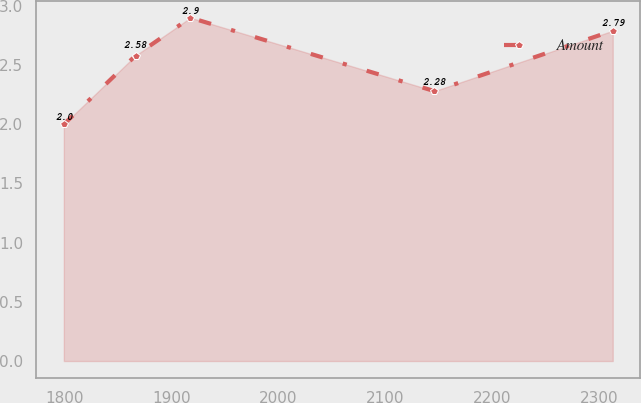Convert chart to OTSL. <chart><loc_0><loc_0><loc_500><loc_500><line_chart><ecel><fcel>Amount<nl><fcel>1799.55<fcel>2<nl><fcel>1866.58<fcel>2.58<nl><fcel>1917.88<fcel>2.9<nl><fcel>2145.89<fcel>2.28<nl><fcel>2312.51<fcel>2.79<nl></chart> 